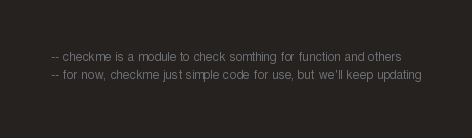<code> <loc_0><loc_0><loc_500><loc_500><_Lua_>-- checkme is a module to check somthing for function and others
-- for now, checkme just simple code for use, but we'll keep updating</code> 